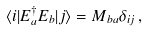Convert formula to latex. <formula><loc_0><loc_0><loc_500><loc_500>\langle i | E _ { a } ^ { \dag } E _ { b } | j \rangle = M _ { b a } \delta _ { i j } \, ,</formula> 